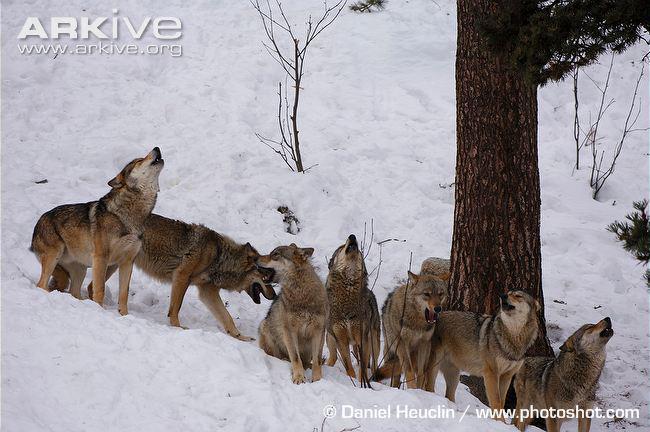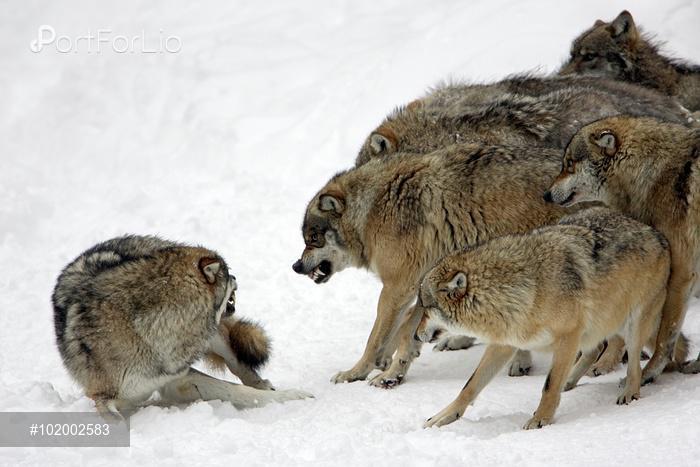The first image is the image on the left, the second image is the image on the right. For the images displayed, is the sentence "One image shows a single wolf in confrontation with a group of wolves that outnumber it about 5-to1." factually correct? Answer yes or no. Yes. The first image is the image on the left, the second image is the image on the right. Analyze the images presented: Is the assertion "The right image contains exactly two wolves." valid? Answer yes or no. No. 